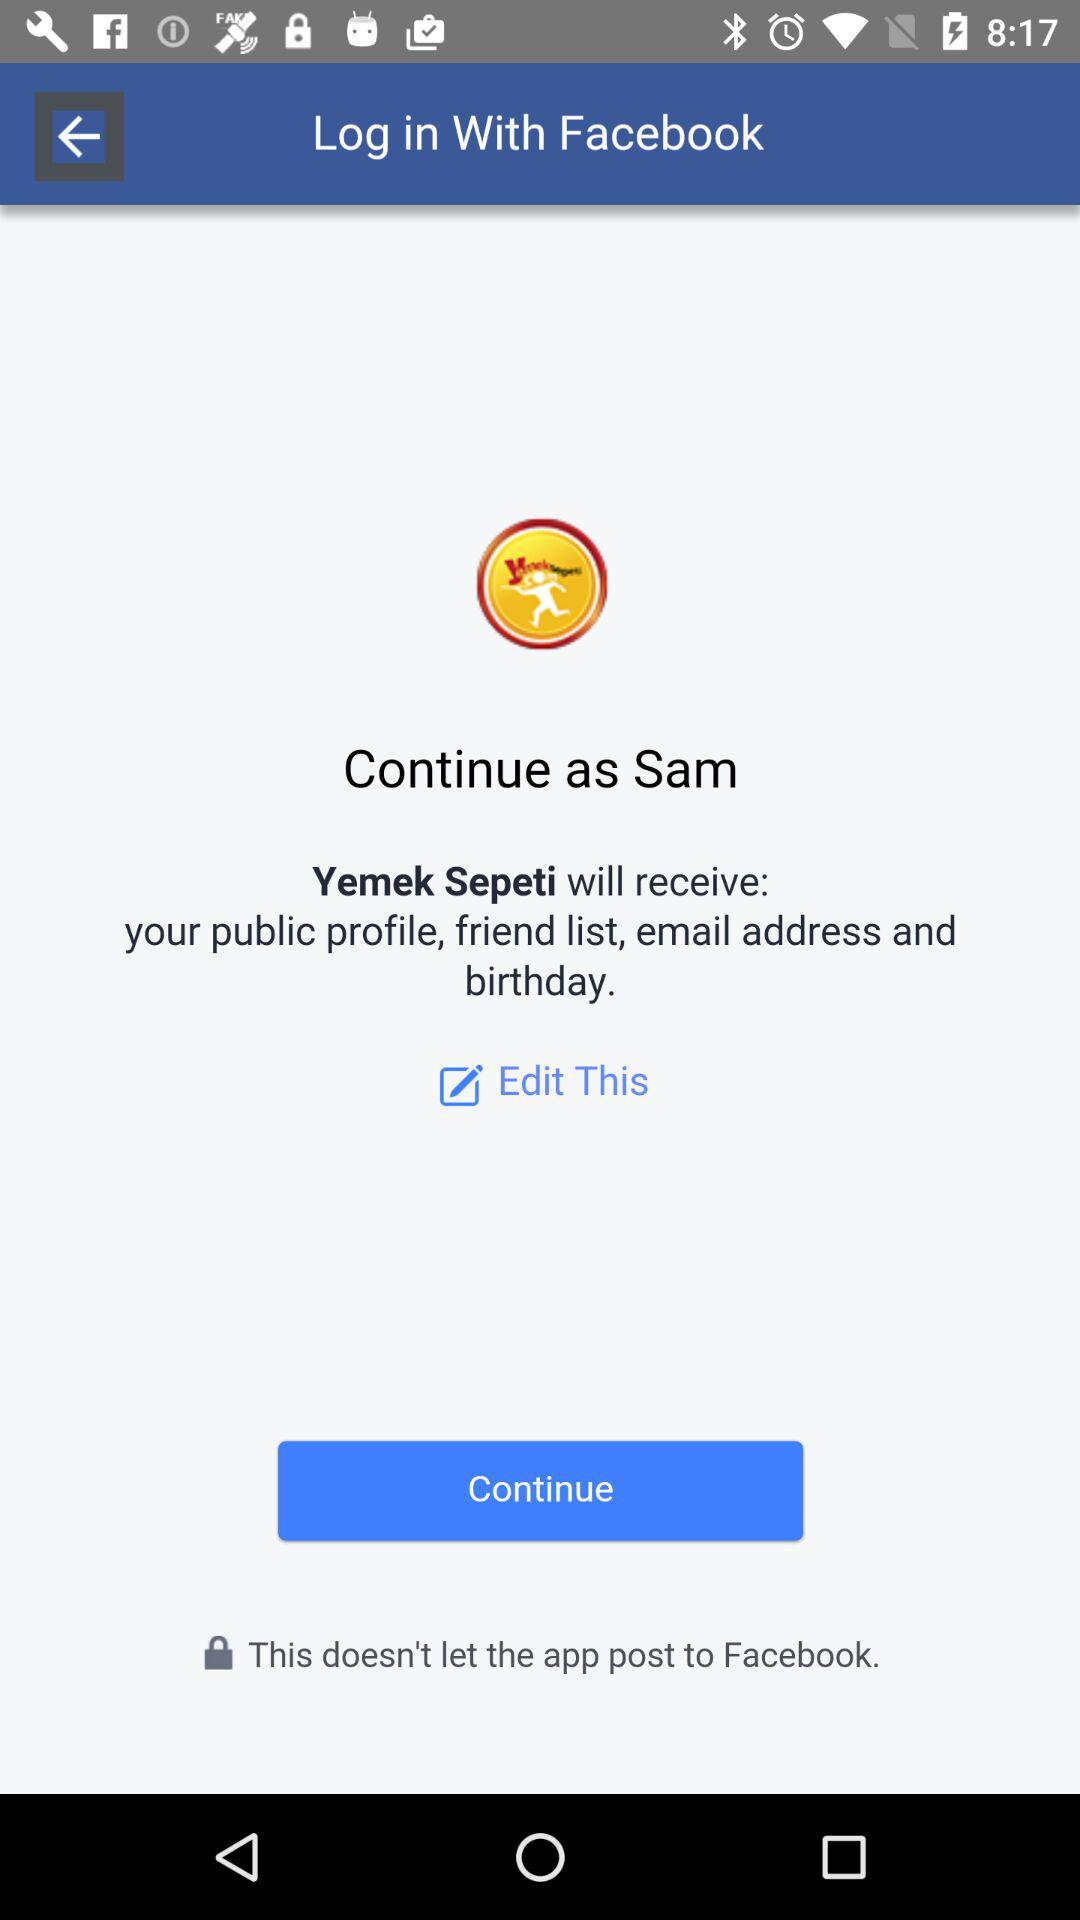What is the user name? The user name is Sam. 